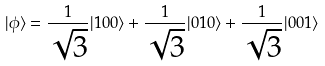<formula> <loc_0><loc_0><loc_500><loc_500>| \phi \rangle = \frac { 1 } { \sqrt { 3 } } | 1 0 0 \rangle + \frac { 1 } { \sqrt { 3 } } | 0 1 0 \rangle + \frac { 1 } { \sqrt { 3 } } | 0 0 1 \rangle</formula> 